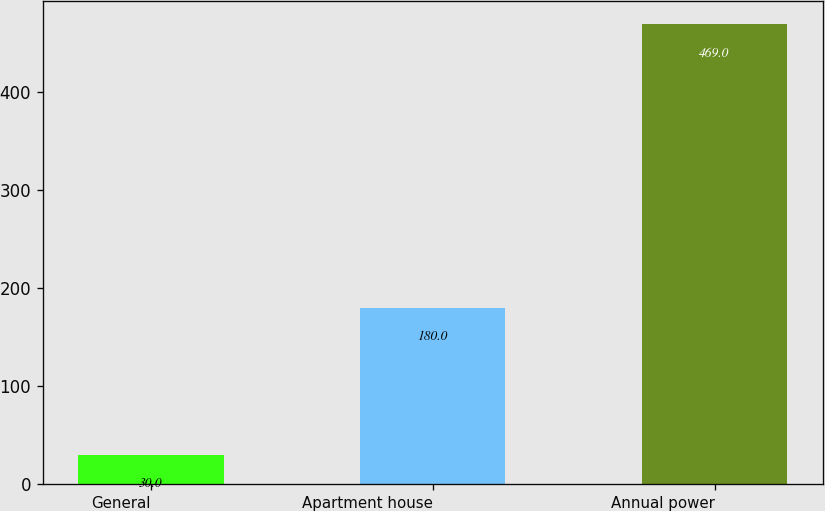Convert chart to OTSL. <chart><loc_0><loc_0><loc_500><loc_500><bar_chart><fcel>General<fcel>Apartment house<fcel>Annual power<nl><fcel>30<fcel>180<fcel>469<nl></chart> 